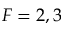Convert formula to latex. <formula><loc_0><loc_0><loc_500><loc_500>F = 2 , 3</formula> 